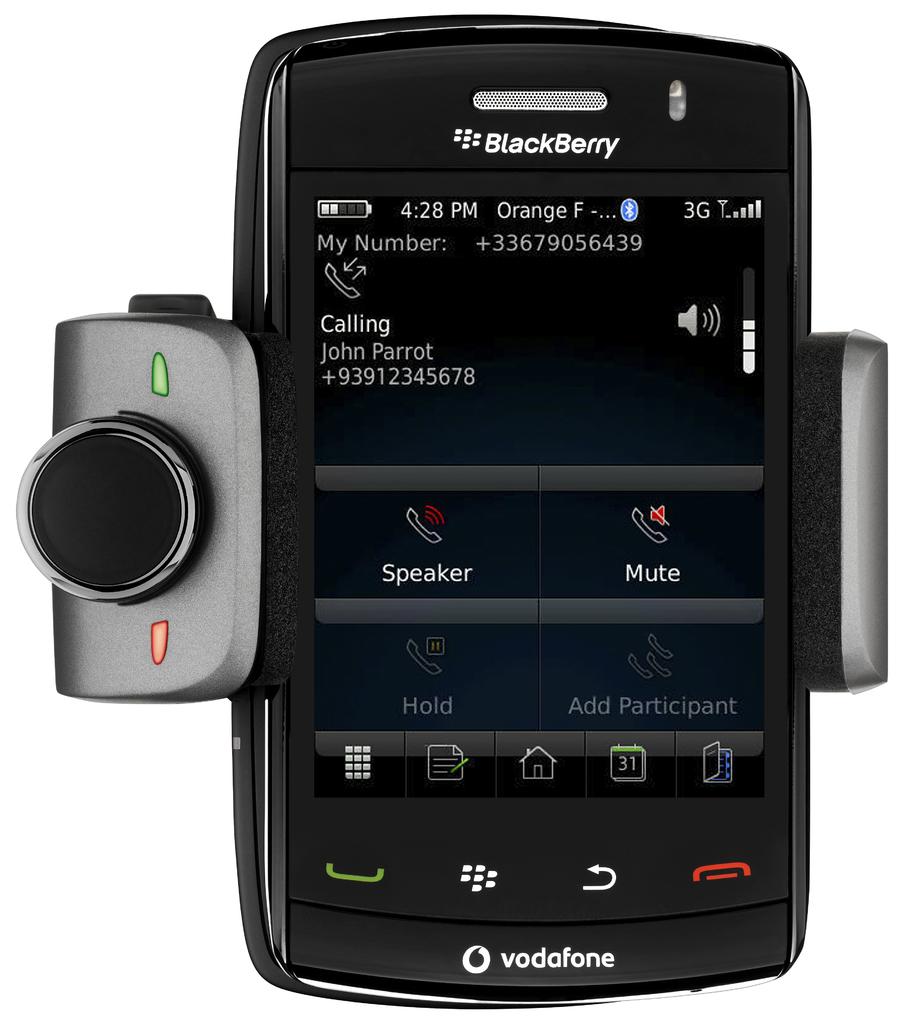What brand phone is this?
Your answer should be very brief. Blackberry. What time is shown here?
Your answer should be compact. 4:28. 